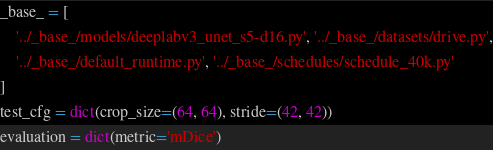<code> <loc_0><loc_0><loc_500><loc_500><_Python_>_base_ = [
    '../_base_/models/deeplabv3_unet_s5-d16.py', '../_base_/datasets/drive.py',
    '../_base_/default_runtime.py', '../_base_/schedules/schedule_40k.py'
]
test_cfg = dict(crop_size=(64, 64), stride=(42, 42))
evaluation = dict(metric='mDice')
</code> 